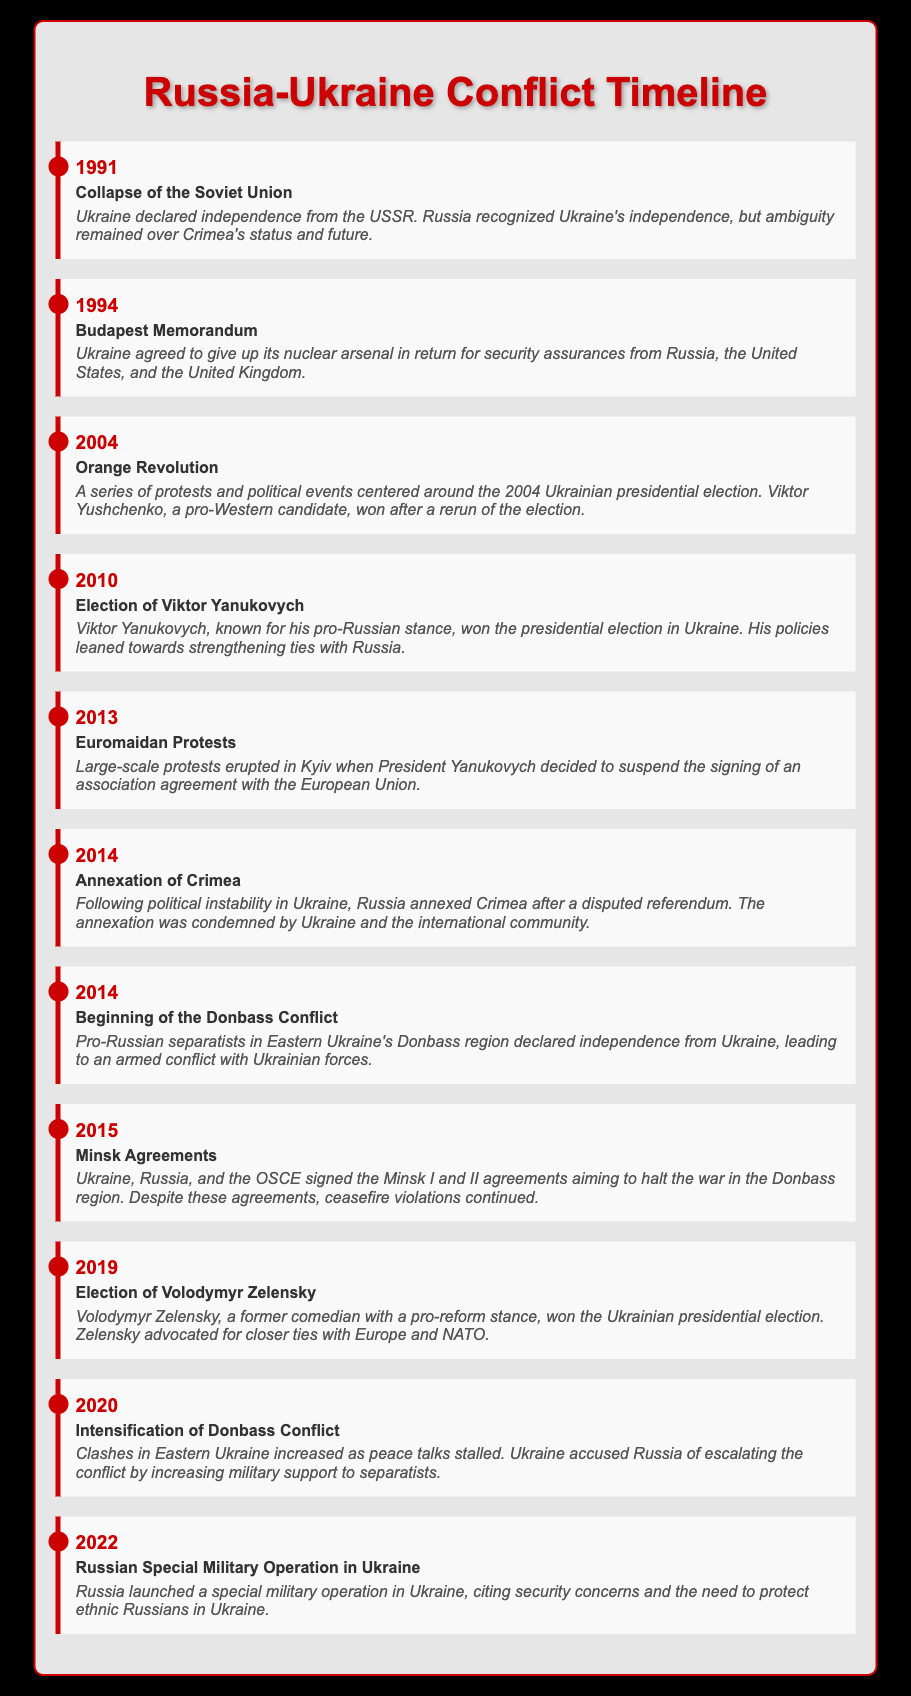What year did Ukraine declare independence? The document states that Ukraine declared independence in 1991.
Answer: 1991 What major event took place in 2014 after the Euromaidan Protests? The document indicates that Russia annexed Crimea following political instability in Ukraine.
Answer: Annexation of Crimea Who was elected president of Ukraine in 2019? The document notes that Volodymyr Zelensky won the presidential election in Ukraine in 2019.
Answer: Volodymyr Zelensky What were the Minsk Agreements aiming to achieve? The document reveals that the Minsk Agreements aimed to halt the war in the Donbass region.
Answer: Halt the war In what year did the Donbass conflict begin? According to the document, the conflict began in 2014 when pro-Russian separatists declared independence.
Answer: 2014 What was a significant outcome of the 1994 Budapest Memorandum? The document states that Ukraine agreed to give up its nuclear arsenal in return for security assurances.
Answer: Security assurances How many major events are highlighted for the year 2014? The document lists two significant events for the year 2014: Annexation of Crimea and Beginning of the Donbass Conflict.
Answer: Two What was the primary reason given by Russia for the 2022 military operation in Ukraine? The document mentions that Russia cited security concerns and the need to protect ethnic Russians in Ukraine.
Answer: Security concerns and protection of ethnic Russians 